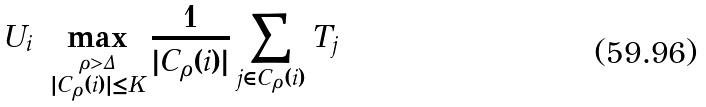Convert formula to latex. <formula><loc_0><loc_0><loc_500><loc_500>U _ { i } = \max _ { \stackrel { \rho > \Delta } { | C _ { \rho } ( i ) | \leq K } } \frac { 1 } { | C _ { \rho } ( i ) | } \sum _ { j \in C _ { \rho } ( i ) } T _ { j }</formula> 